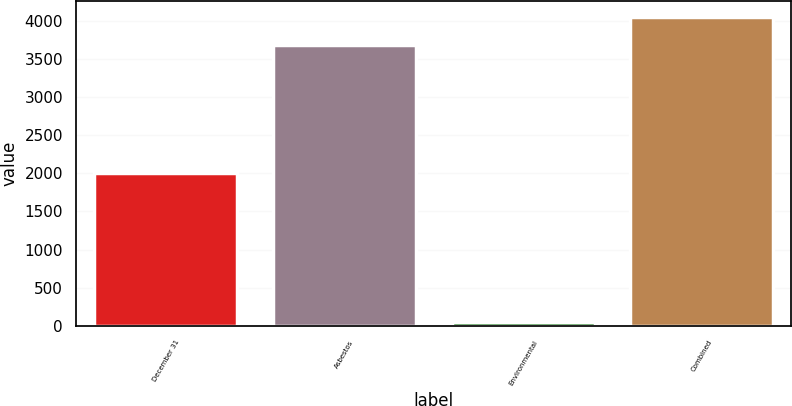Convert chart to OTSL. <chart><loc_0><loc_0><loc_500><loc_500><bar_chart><fcel>December 31<fcel>Asbestos<fcel>Environmental<fcel>Combined<nl><fcel>2011<fcel>3685<fcel>57<fcel>4053.5<nl></chart> 